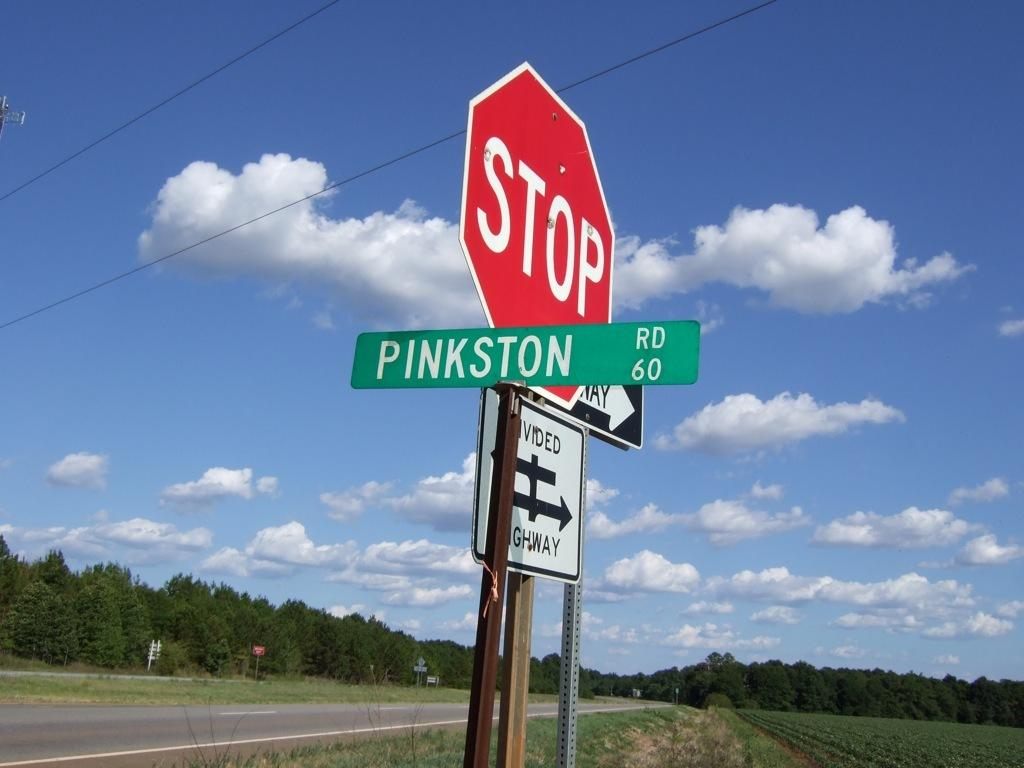<image>
Give a short and clear explanation of the subsequent image. a stop sign that is red in color 